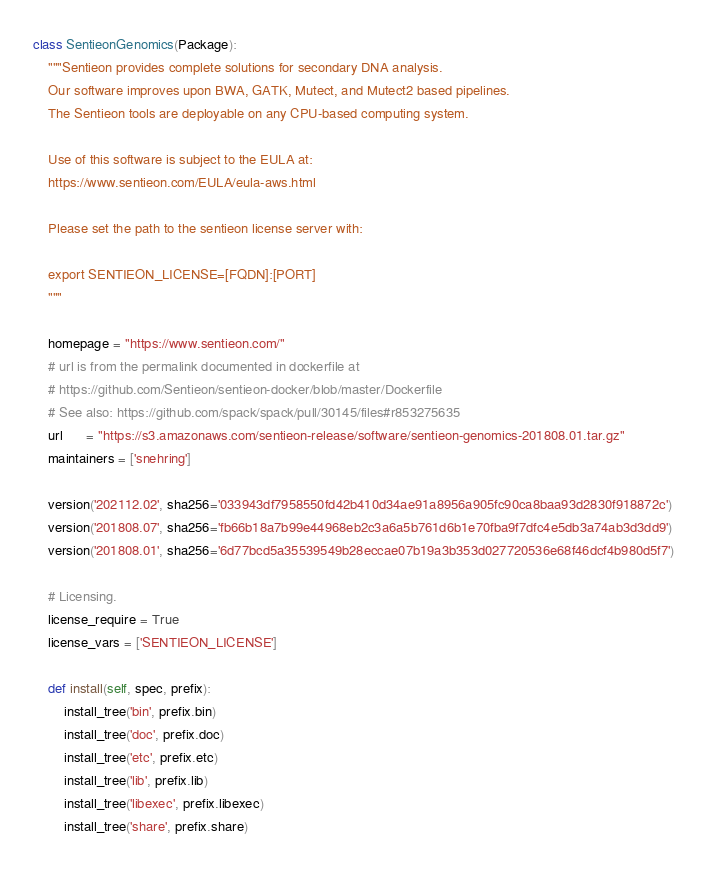<code> <loc_0><loc_0><loc_500><loc_500><_Python_>
class SentieonGenomics(Package):
    """Sentieon provides complete solutions for secondary DNA analysis.
    Our software improves upon BWA, GATK, Mutect, and Mutect2 based pipelines.
    The Sentieon tools are deployable on any CPU-based computing system.

    Use of this software is subject to the EULA at:
    https://www.sentieon.com/EULA/eula-aws.html

    Please set the path to the sentieon license server with:

    export SENTIEON_LICENSE=[FQDN]:[PORT]
    """

    homepage = "https://www.sentieon.com/"
    # url is from the permalink documented in dockerfile at
    # https://github.com/Sentieon/sentieon-docker/blob/master/Dockerfile
    # See also: https://github.com/spack/spack/pull/30145/files#r853275635
    url      = "https://s3.amazonaws.com/sentieon-release/software/sentieon-genomics-201808.01.tar.gz"
    maintainers = ['snehring']

    version('202112.02', sha256='033943df7958550fd42b410d34ae91a8956a905fc90ca8baa93d2830f918872c')
    version('201808.07', sha256='fb66b18a7b99e44968eb2c3a6a5b761d6b1e70fba9f7dfc4e5db3a74ab3d3dd9')
    version('201808.01', sha256='6d77bcd5a35539549b28eccae07b19a3b353d027720536e68f46dcf4b980d5f7')

    # Licensing.
    license_require = True
    license_vars = ['SENTIEON_LICENSE']

    def install(self, spec, prefix):
        install_tree('bin', prefix.bin)
        install_tree('doc', prefix.doc)
        install_tree('etc', prefix.etc)
        install_tree('lib', prefix.lib)
        install_tree('libexec', prefix.libexec)
        install_tree('share', prefix.share)
</code> 